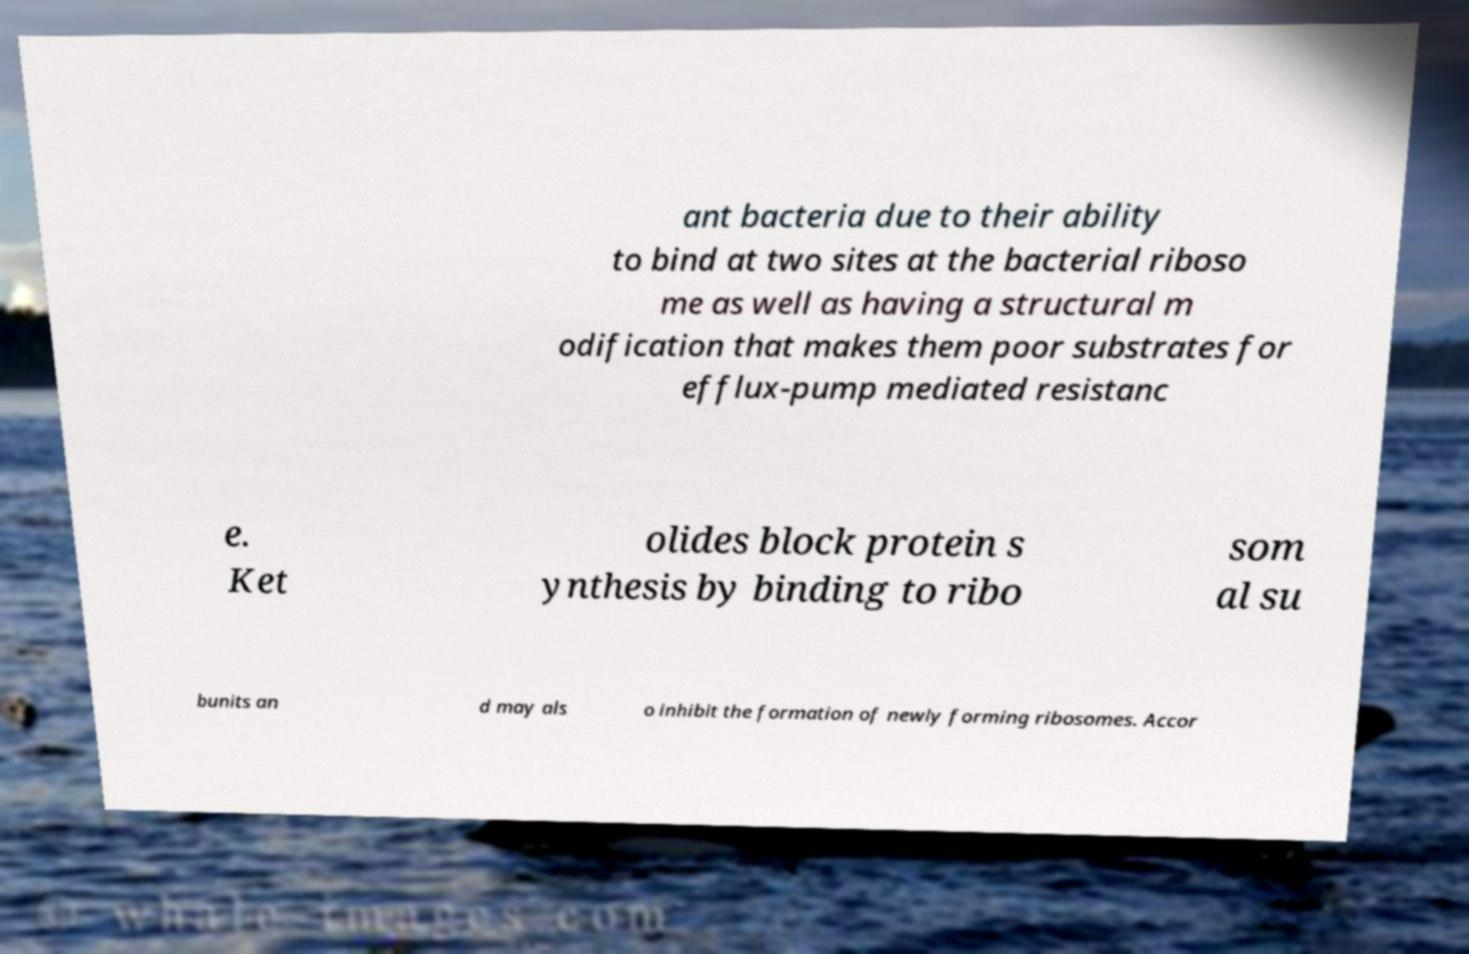There's text embedded in this image that I need extracted. Can you transcribe it verbatim? ant bacteria due to their ability to bind at two sites at the bacterial riboso me as well as having a structural m odification that makes them poor substrates for efflux-pump mediated resistanc e. Ket olides block protein s ynthesis by binding to ribo som al su bunits an d may als o inhibit the formation of newly forming ribosomes. Accor 